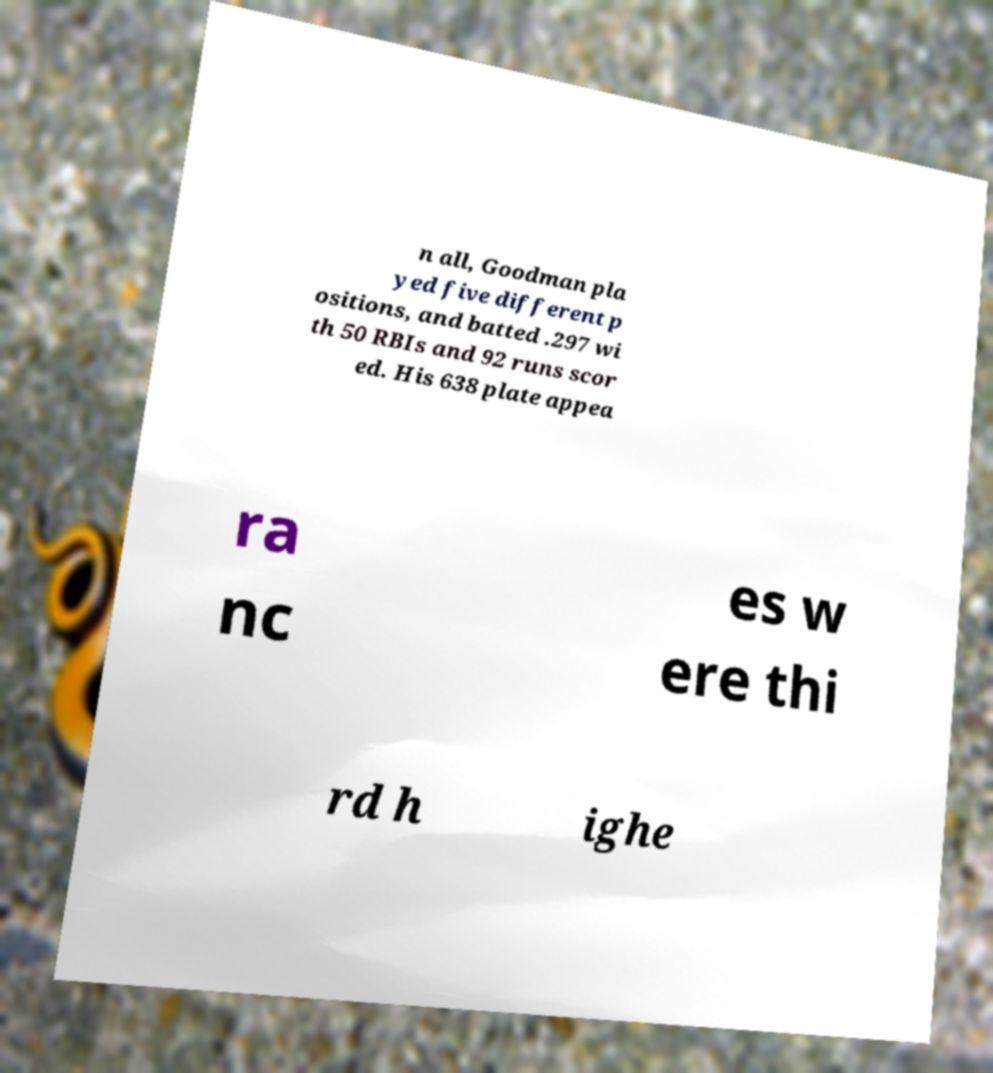What messages or text are displayed in this image? I need them in a readable, typed format. n all, Goodman pla yed five different p ositions, and batted .297 wi th 50 RBIs and 92 runs scor ed. His 638 plate appea ra nc es w ere thi rd h ighe 